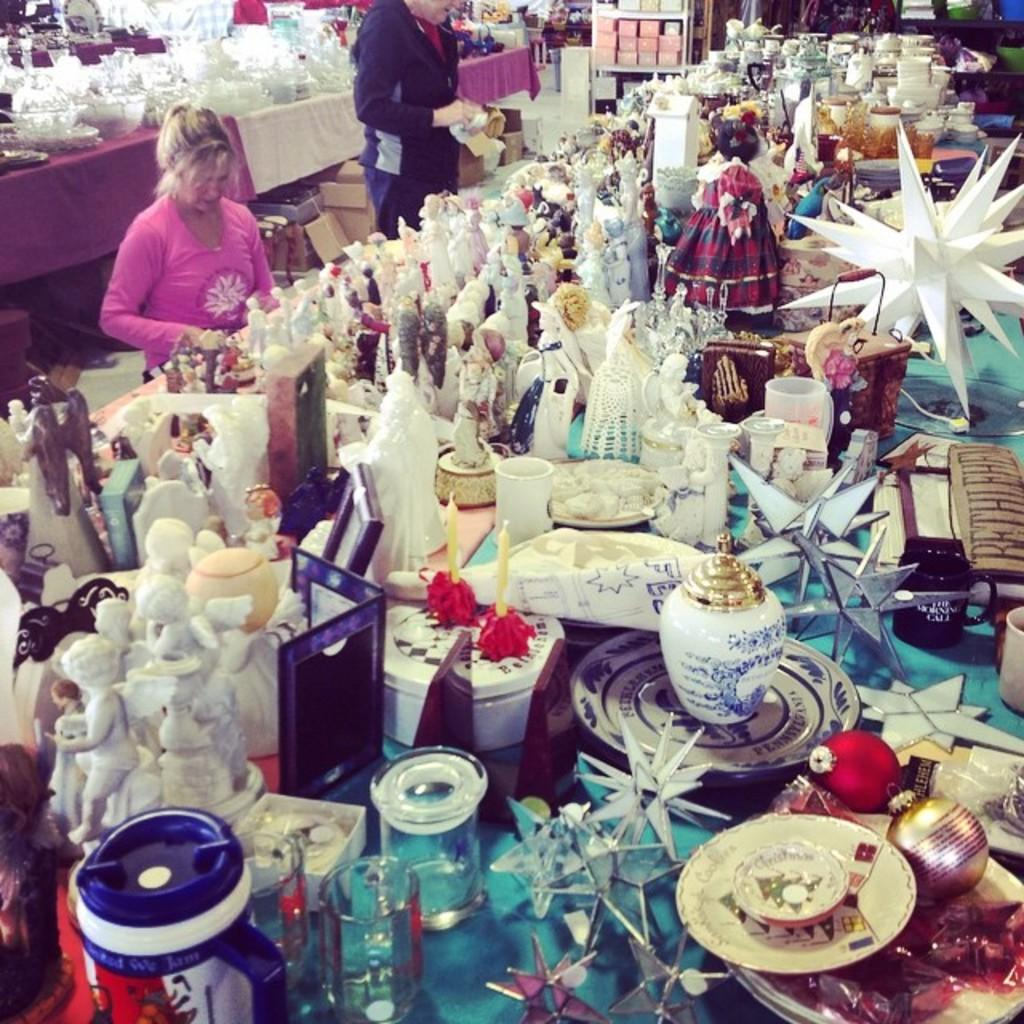What can be seen in the image in terms of artistic creations? There are many sculptures in the image. Where are the sculptures located? The sculptures are on a table in the image. Who is present in the image? There is a woman and a man in the image. What are the woman and the man doing in the image? The woman and the man are working near a sculpture. How many apples are being transported by the woman in the image? There are no apples or any form of transportation present in the image. 